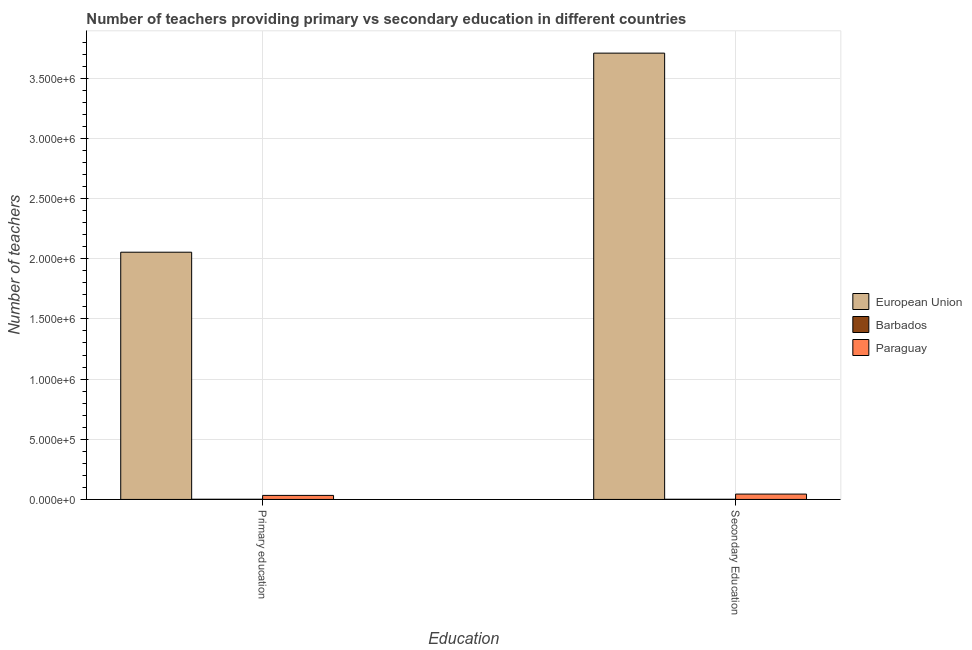How many different coloured bars are there?
Provide a short and direct response. 3. How many bars are there on the 2nd tick from the left?
Ensure brevity in your answer.  3. How many bars are there on the 2nd tick from the right?
Make the answer very short. 3. What is the number of secondary teachers in Paraguay?
Keep it short and to the point. 4.44e+04. Across all countries, what is the maximum number of primary teachers?
Ensure brevity in your answer.  2.05e+06. Across all countries, what is the minimum number of primary teachers?
Your answer should be compact. 1416. In which country was the number of secondary teachers minimum?
Provide a short and direct response. Barbados. What is the total number of primary teachers in the graph?
Ensure brevity in your answer.  2.09e+06. What is the difference between the number of primary teachers in Barbados and that in European Union?
Your answer should be very brief. -2.05e+06. What is the difference between the number of primary teachers in Paraguay and the number of secondary teachers in Barbados?
Keep it short and to the point. 3.22e+04. What is the average number of secondary teachers per country?
Offer a terse response. 1.25e+06. What is the difference between the number of primary teachers and number of secondary teachers in European Union?
Give a very brief answer. -1.65e+06. In how many countries, is the number of secondary teachers greater than 3000000 ?
Offer a terse response. 1. What is the ratio of the number of primary teachers in Barbados to that in European Union?
Provide a succinct answer. 0. In how many countries, is the number of primary teachers greater than the average number of primary teachers taken over all countries?
Make the answer very short. 1. What does the 2nd bar from the left in Secondary Education represents?
Your answer should be very brief. Barbados. What does the 1st bar from the right in Secondary Education represents?
Offer a very short reply. Paraguay. How many bars are there?
Make the answer very short. 6. What is the difference between two consecutive major ticks on the Y-axis?
Offer a terse response. 5.00e+05. Are the values on the major ticks of Y-axis written in scientific E-notation?
Offer a terse response. Yes. Does the graph contain any zero values?
Ensure brevity in your answer.  No. Does the graph contain grids?
Provide a succinct answer. Yes. Where does the legend appear in the graph?
Give a very brief answer. Center right. How many legend labels are there?
Make the answer very short. 3. How are the legend labels stacked?
Ensure brevity in your answer.  Vertical. What is the title of the graph?
Your answer should be compact. Number of teachers providing primary vs secondary education in different countries. Does "Canada" appear as one of the legend labels in the graph?
Ensure brevity in your answer.  No. What is the label or title of the X-axis?
Your answer should be very brief. Education. What is the label or title of the Y-axis?
Your response must be concise. Number of teachers. What is the Number of teachers of European Union in Primary education?
Ensure brevity in your answer.  2.05e+06. What is the Number of teachers in Barbados in Primary education?
Provide a short and direct response. 1416. What is the Number of teachers in Paraguay in Primary education?
Provide a succinct answer. 3.34e+04. What is the Number of teachers of European Union in Secondary Education?
Offer a terse response. 3.71e+06. What is the Number of teachers of Barbados in Secondary Education?
Your answer should be very brief. 1264. What is the Number of teachers of Paraguay in Secondary Education?
Make the answer very short. 4.44e+04. Across all Education, what is the maximum Number of teachers in European Union?
Your response must be concise. 3.71e+06. Across all Education, what is the maximum Number of teachers in Barbados?
Offer a very short reply. 1416. Across all Education, what is the maximum Number of teachers of Paraguay?
Offer a very short reply. 4.44e+04. Across all Education, what is the minimum Number of teachers in European Union?
Give a very brief answer. 2.05e+06. Across all Education, what is the minimum Number of teachers in Barbados?
Provide a succinct answer. 1264. Across all Education, what is the minimum Number of teachers of Paraguay?
Provide a succinct answer. 3.34e+04. What is the total Number of teachers in European Union in the graph?
Your answer should be compact. 5.76e+06. What is the total Number of teachers of Barbados in the graph?
Make the answer very short. 2680. What is the total Number of teachers of Paraguay in the graph?
Make the answer very short. 7.79e+04. What is the difference between the Number of teachers in European Union in Primary education and that in Secondary Education?
Provide a short and direct response. -1.65e+06. What is the difference between the Number of teachers of Barbados in Primary education and that in Secondary Education?
Provide a succinct answer. 152. What is the difference between the Number of teachers in Paraguay in Primary education and that in Secondary Education?
Provide a short and direct response. -1.10e+04. What is the difference between the Number of teachers of European Union in Primary education and the Number of teachers of Barbados in Secondary Education?
Give a very brief answer. 2.05e+06. What is the difference between the Number of teachers of European Union in Primary education and the Number of teachers of Paraguay in Secondary Education?
Your answer should be very brief. 2.01e+06. What is the difference between the Number of teachers in Barbados in Primary education and the Number of teachers in Paraguay in Secondary Education?
Offer a terse response. -4.30e+04. What is the average Number of teachers of European Union per Education?
Give a very brief answer. 2.88e+06. What is the average Number of teachers in Barbados per Education?
Give a very brief answer. 1340. What is the average Number of teachers of Paraguay per Education?
Your answer should be very brief. 3.89e+04. What is the difference between the Number of teachers of European Union and Number of teachers of Barbados in Primary education?
Provide a succinct answer. 2.05e+06. What is the difference between the Number of teachers in European Union and Number of teachers in Paraguay in Primary education?
Offer a very short reply. 2.02e+06. What is the difference between the Number of teachers of Barbados and Number of teachers of Paraguay in Primary education?
Offer a terse response. -3.20e+04. What is the difference between the Number of teachers of European Union and Number of teachers of Barbados in Secondary Education?
Your answer should be compact. 3.71e+06. What is the difference between the Number of teachers in European Union and Number of teachers in Paraguay in Secondary Education?
Offer a very short reply. 3.66e+06. What is the difference between the Number of teachers of Barbados and Number of teachers of Paraguay in Secondary Education?
Offer a very short reply. -4.32e+04. What is the ratio of the Number of teachers in European Union in Primary education to that in Secondary Education?
Give a very brief answer. 0.55. What is the ratio of the Number of teachers in Barbados in Primary education to that in Secondary Education?
Ensure brevity in your answer.  1.12. What is the ratio of the Number of teachers in Paraguay in Primary education to that in Secondary Education?
Your answer should be compact. 0.75. What is the difference between the highest and the second highest Number of teachers in European Union?
Give a very brief answer. 1.65e+06. What is the difference between the highest and the second highest Number of teachers in Barbados?
Provide a short and direct response. 152. What is the difference between the highest and the second highest Number of teachers in Paraguay?
Offer a terse response. 1.10e+04. What is the difference between the highest and the lowest Number of teachers of European Union?
Provide a short and direct response. 1.65e+06. What is the difference between the highest and the lowest Number of teachers of Barbados?
Give a very brief answer. 152. What is the difference between the highest and the lowest Number of teachers in Paraguay?
Offer a very short reply. 1.10e+04. 